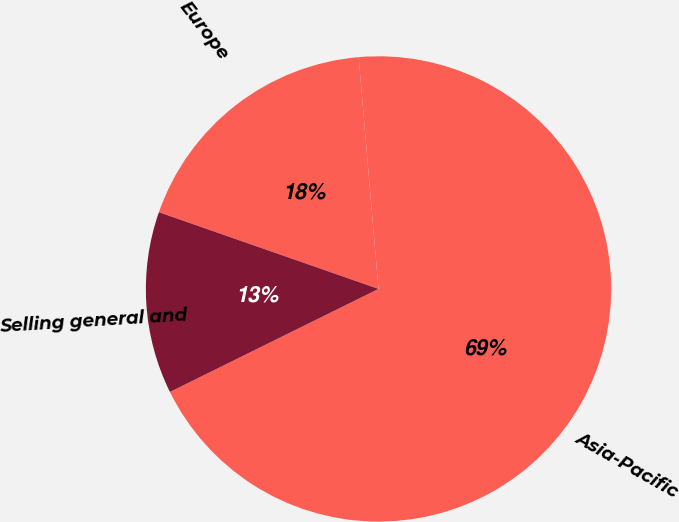Convert chart to OTSL. <chart><loc_0><loc_0><loc_500><loc_500><pie_chart><fcel>Europe<fcel>Asia-Pacific<fcel>Selling general and<nl><fcel>18.29%<fcel>69.06%<fcel>12.65%<nl></chart> 